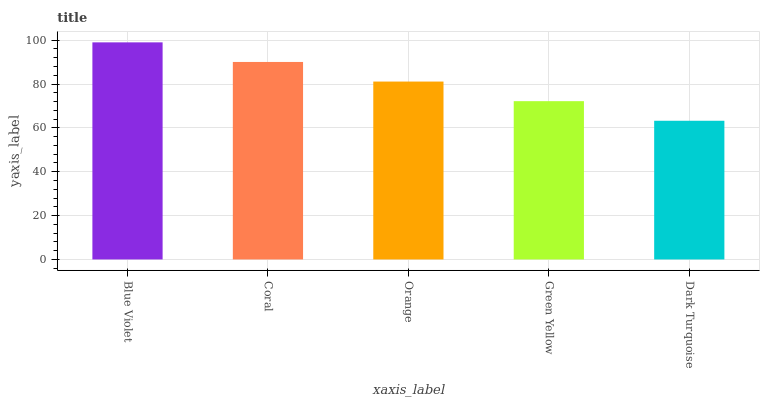Is Dark Turquoise the minimum?
Answer yes or no. Yes. Is Blue Violet the maximum?
Answer yes or no. Yes. Is Coral the minimum?
Answer yes or no. No. Is Coral the maximum?
Answer yes or no. No. Is Blue Violet greater than Coral?
Answer yes or no. Yes. Is Coral less than Blue Violet?
Answer yes or no. Yes. Is Coral greater than Blue Violet?
Answer yes or no. No. Is Blue Violet less than Coral?
Answer yes or no. No. Is Orange the high median?
Answer yes or no. Yes. Is Orange the low median?
Answer yes or no. Yes. Is Green Yellow the high median?
Answer yes or no. No. Is Coral the low median?
Answer yes or no. No. 